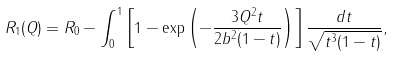Convert formula to latex. <formula><loc_0><loc_0><loc_500><loc_500>R _ { 1 } ( Q ) = R _ { 0 } - \int _ { 0 } ^ { 1 } \left [ 1 - \exp \left ( - \frac { 3 Q ^ { 2 } t } { 2 b ^ { 2 } ( 1 - t ) } \right ) \right ] \frac { d t } { \sqrt { t ^ { 3 } ( 1 - t ) } } ,</formula> 